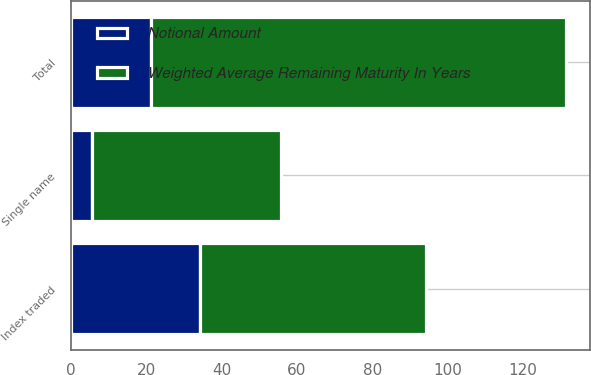Convert chart. <chart><loc_0><loc_0><loc_500><loc_500><stacked_bar_chart><ecel><fcel>Single name<fcel>Index traded<fcel>Total<nl><fcel>Weighted Average Remaining Maturity In Years<fcel>50<fcel>60<fcel>110<nl><fcel>Notional Amount<fcel>5.7<fcel>34.2<fcel>21.3<nl></chart> 